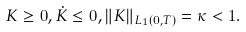Convert formula to latex. <formula><loc_0><loc_0><loc_500><loc_500>K \geq 0 , \dot { K } \leq 0 , \| K \| _ { L _ { 1 } ( 0 , T ) } = \kappa < 1 .</formula> 